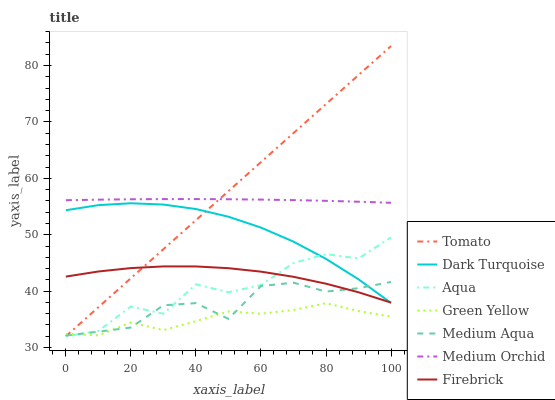Does Green Yellow have the minimum area under the curve?
Answer yes or no. Yes. Does Tomato have the maximum area under the curve?
Answer yes or no. Yes. Does Dark Turquoise have the minimum area under the curve?
Answer yes or no. No. Does Dark Turquoise have the maximum area under the curve?
Answer yes or no. No. Is Tomato the smoothest?
Answer yes or no. Yes. Is Aqua the roughest?
Answer yes or no. Yes. Is Dark Turquoise the smoothest?
Answer yes or no. No. Is Dark Turquoise the roughest?
Answer yes or no. No. Does Tomato have the lowest value?
Answer yes or no. Yes. Does Dark Turquoise have the lowest value?
Answer yes or no. No. Does Tomato have the highest value?
Answer yes or no. Yes. Does Dark Turquoise have the highest value?
Answer yes or no. No. Is Medium Aqua less than Medium Orchid?
Answer yes or no. Yes. Is Medium Orchid greater than Aqua?
Answer yes or no. Yes. Does Aqua intersect Firebrick?
Answer yes or no. Yes. Is Aqua less than Firebrick?
Answer yes or no. No. Is Aqua greater than Firebrick?
Answer yes or no. No. Does Medium Aqua intersect Medium Orchid?
Answer yes or no. No. 